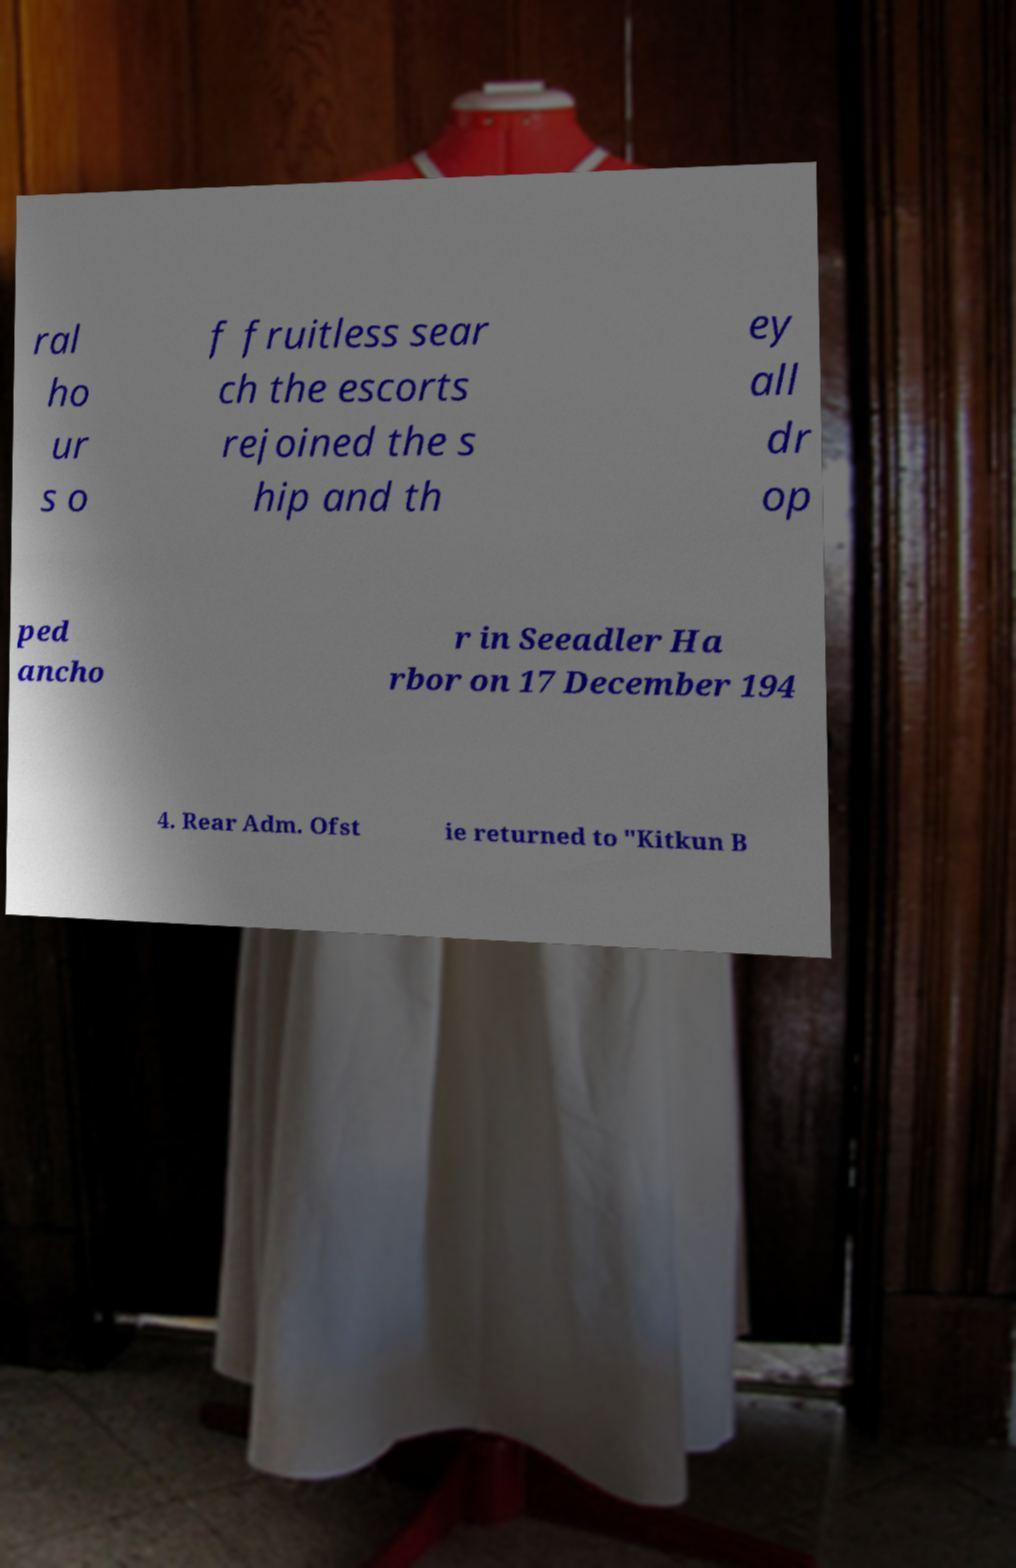Please read and relay the text visible in this image. What does it say? ral ho ur s o f fruitless sear ch the escorts rejoined the s hip and th ey all dr op ped ancho r in Seeadler Ha rbor on 17 December 194 4. Rear Adm. Ofst ie returned to "Kitkun B 